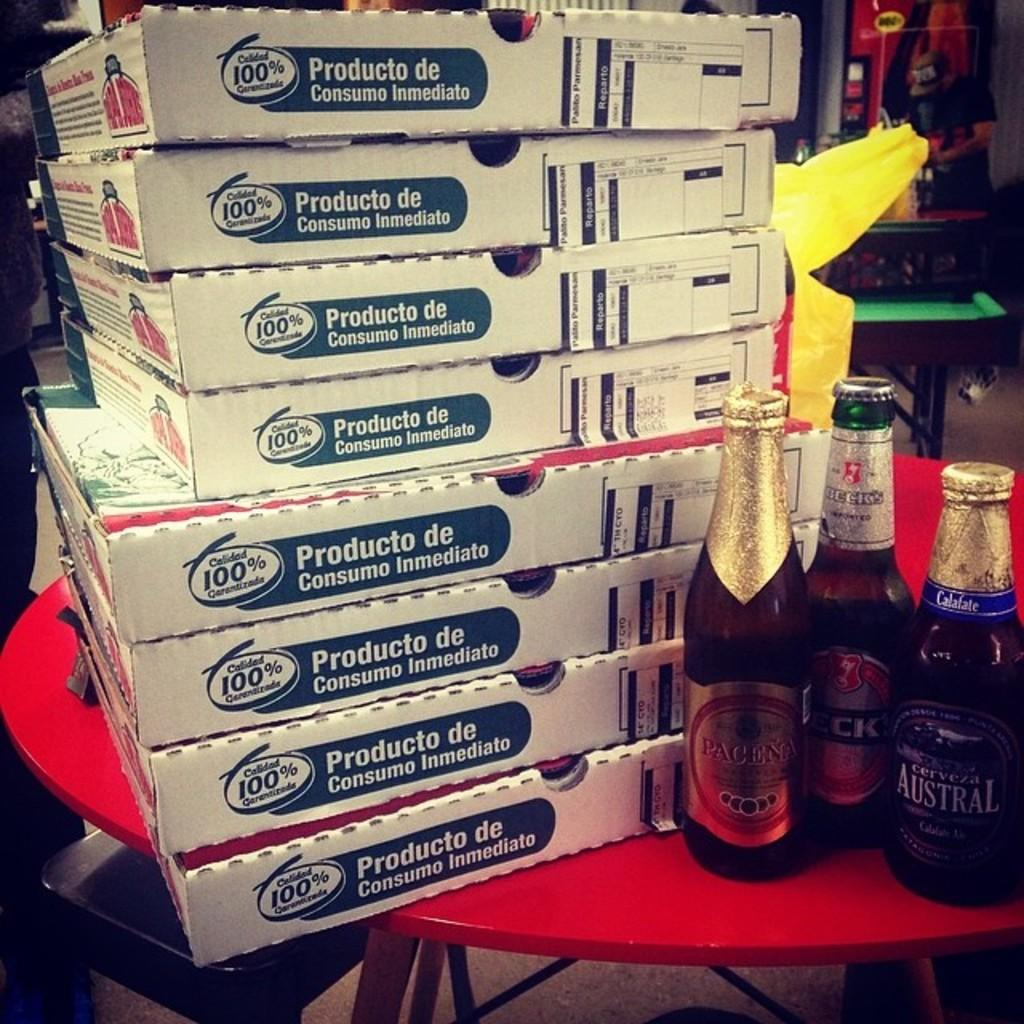<image>
Describe the image concisely. several pizza boxes are stacked beside  Austra and other beer bottles 